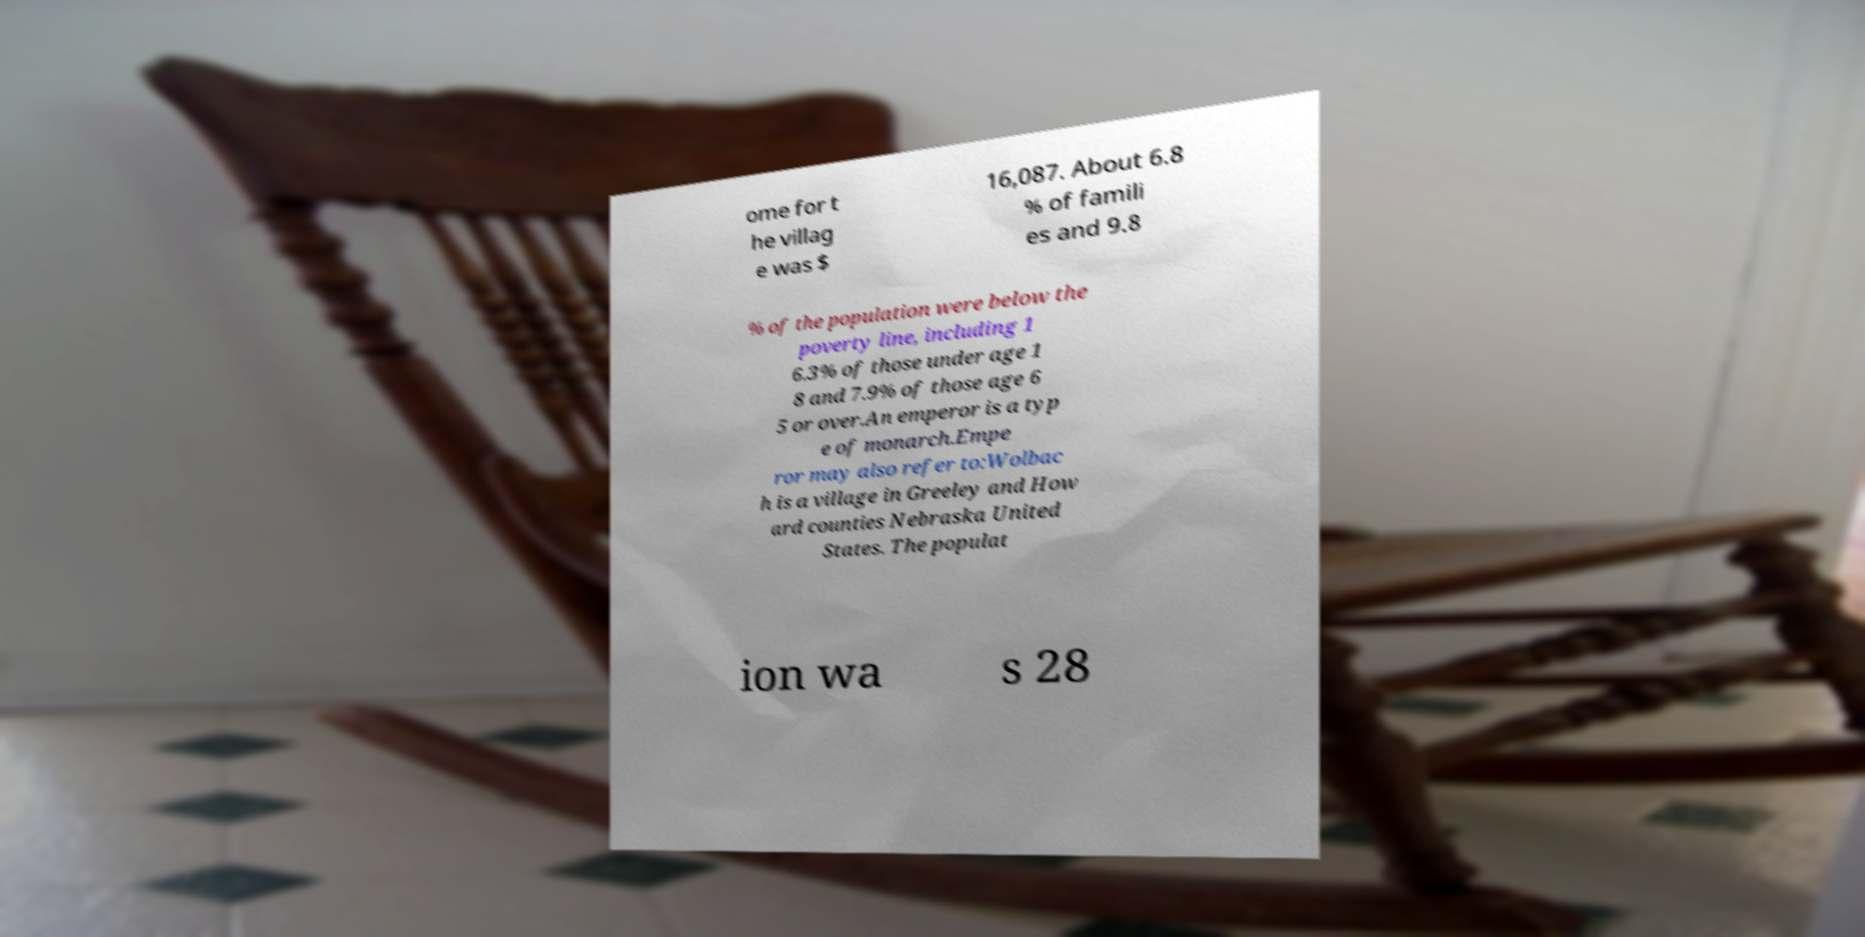Could you extract and type out the text from this image? ome for t he villag e was $ 16,087. About 6.8 % of famili es and 9.8 % of the population were below the poverty line, including 1 6.3% of those under age 1 8 and 7.9% of those age 6 5 or over.An emperor is a typ e of monarch.Empe ror may also refer to:Wolbac h is a village in Greeley and How ard counties Nebraska United States. The populat ion wa s 28 